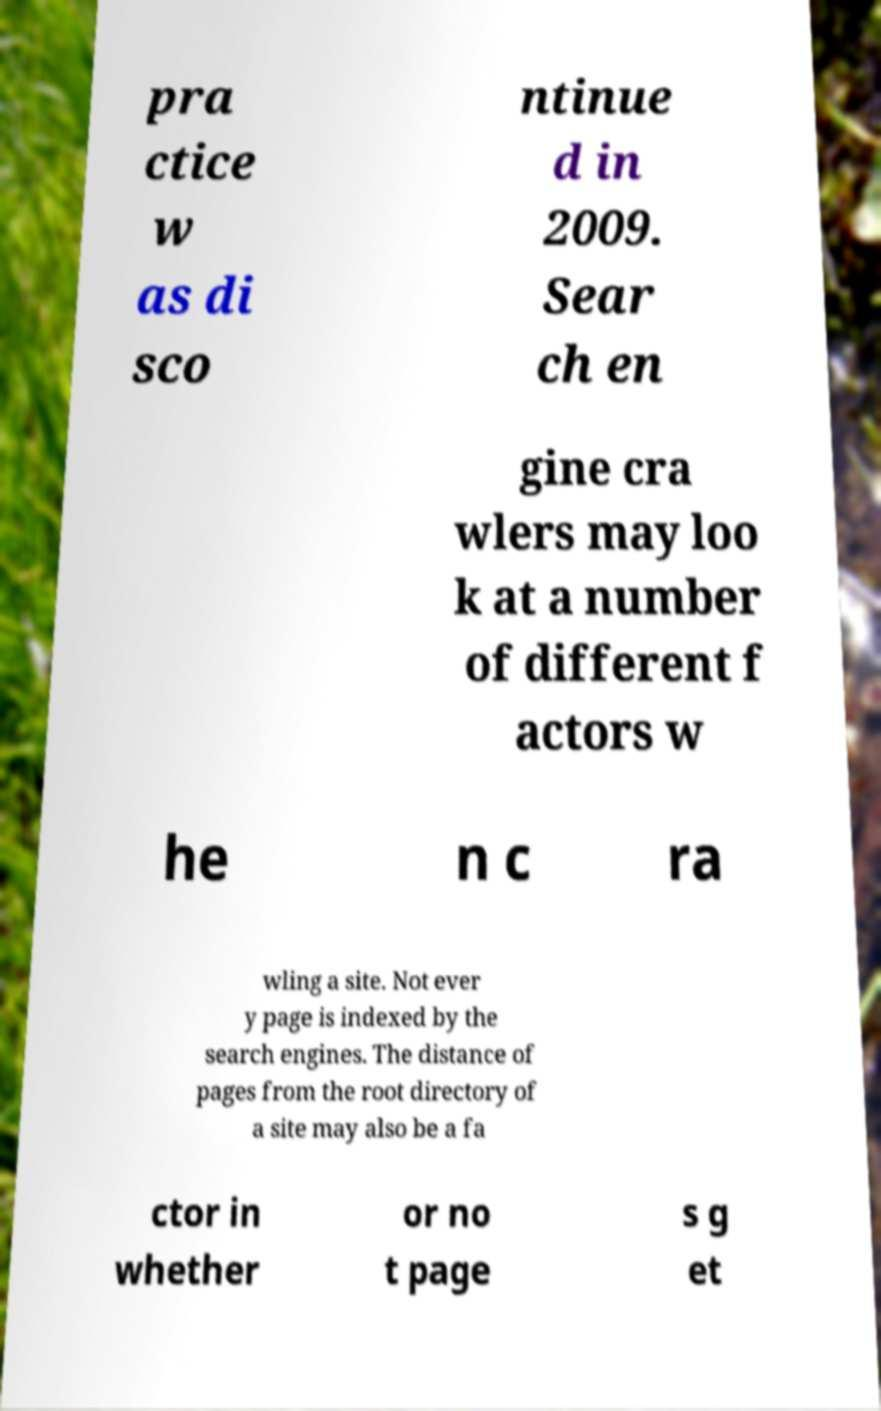Please identify and transcribe the text found in this image. pra ctice w as di sco ntinue d in 2009. Sear ch en gine cra wlers may loo k at a number of different f actors w he n c ra wling a site. Not ever y page is indexed by the search engines. The distance of pages from the root directory of a site may also be a fa ctor in whether or no t page s g et 